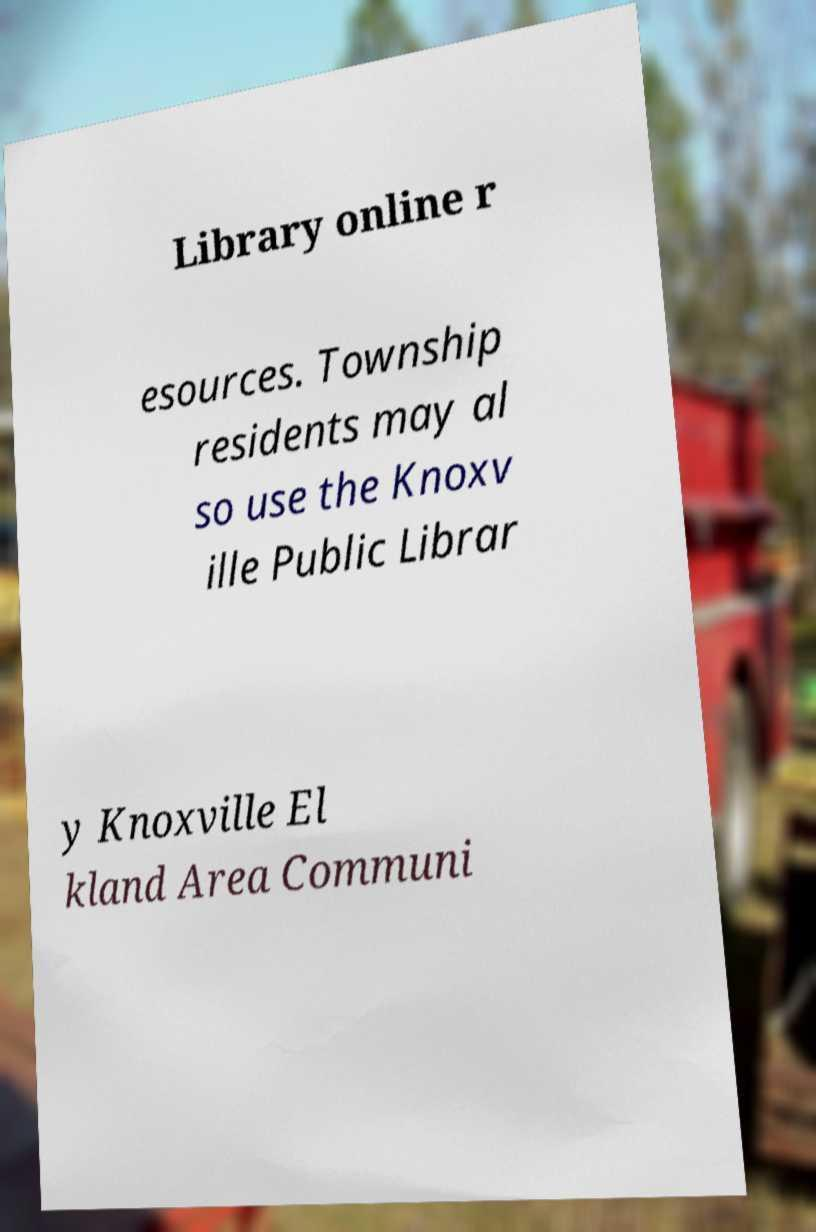I need the written content from this picture converted into text. Can you do that? Library online r esources. Township residents may al so use the Knoxv ille Public Librar y Knoxville El kland Area Communi 